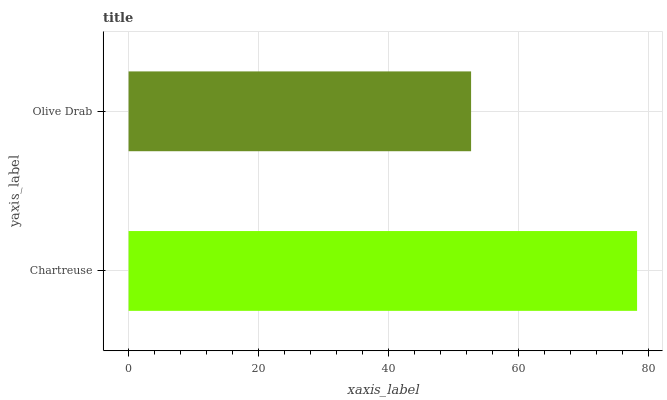Is Olive Drab the minimum?
Answer yes or no. Yes. Is Chartreuse the maximum?
Answer yes or no. Yes. Is Olive Drab the maximum?
Answer yes or no. No. Is Chartreuse greater than Olive Drab?
Answer yes or no. Yes. Is Olive Drab less than Chartreuse?
Answer yes or no. Yes. Is Olive Drab greater than Chartreuse?
Answer yes or no. No. Is Chartreuse less than Olive Drab?
Answer yes or no. No. Is Chartreuse the high median?
Answer yes or no. Yes. Is Olive Drab the low median?
Answer yes or no. Yes. Is Olive Drab the high median?
Answer yes or no. No. Is Chartreuse the low median?
Answer yes or no. No. 